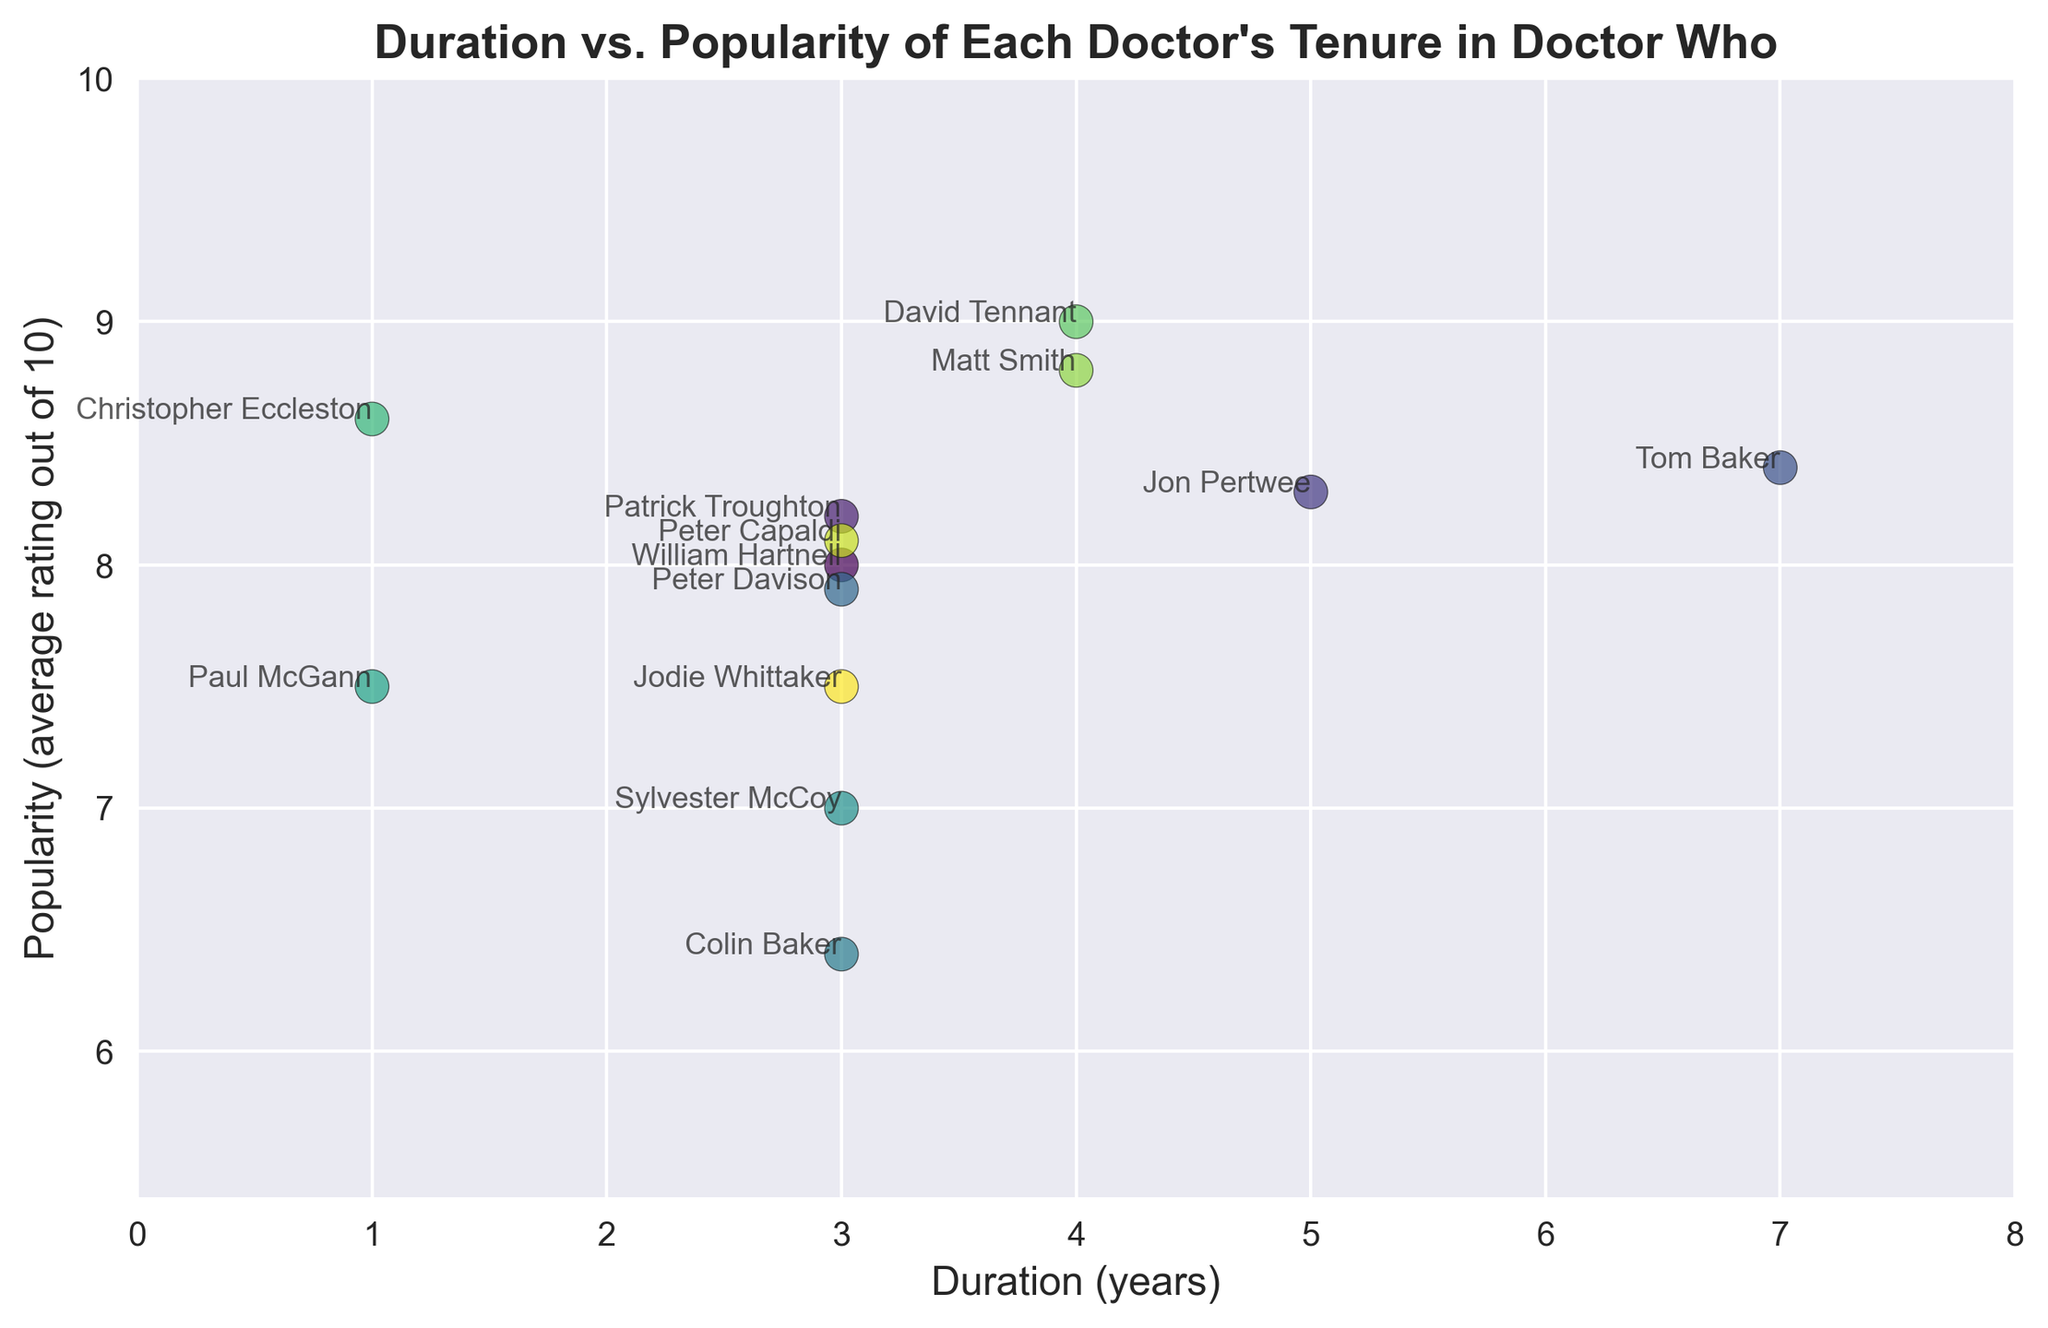Which Doctor had the highest average popularity rating? Look at the y-axis values corresponding to each Doctor. David Tennant has the highest point on the y-axis with a rating of 9.0.
Answer: David Tennant Which Doctor had the lowest average popularity rating? Look at the y-axis values corresponding to each Doctor. Colin Baker has the lowest point on the y-axis with a rating of 6.4.
Answer: Colin Baker What is the total duration of all Doctors who have a popularity rating above 8.0? Identify the Doctors with an average rating above 8.0: William Hartnell, Patrick Troughton, Jon Pertwee, Tom Baker, Christopher Eccleston, David Tennant, Matt Smith, and Peter Capaldi. Sum their durations: 3 + 3 + 5 + 7 + 1 + 4 + 4 + 3 = 30.
Answer: 30 Which Doctor had a tenure duration equal to the average tenure duration for all Doctors? Calculate the average tenure duration: (3 + 3 + 5 + 7 + 3 + 3 + 3 + 1 + 1 + 4 + 4 + 3 + 3) / 13 ≈ 3.23 years. Compare this to each Doctor's duration. None of the durations exactly equal the average.
Answer: None Who are the Doctors with a tenure duration of 3 years, and how do their popularity ratings compare? Identify the Doctors with 3 years tenure: William Hartnell, Patrick Troughton, Peter Davison, Colin Baker, Sylvester McCoy, Peter Capaldi, and Jodie Whittaker. Compare their ratings: 8.0, 8.2, 7.9, 6.4, 7.0, 8.1, and 7.5 respectively. Highest is Patrick Troughton (8.2), and lowest is Colin Baker (6.4).
Answer: Patrick Troughton, Colin Baker What is the average rating for Doctors who served less than 4 years? Identify the Doctors who served less than 4 years: William Hartnell, Patrick Troughton, Peter Davison, Colin Baker, Sylvester McCoy, Paul McGann, Christopher Eccleston, and Jodie Whittaker. Their ratings: 8.0, 8.2, 7.9, 6.4, 7.0, 7.5, 8.6, 7.5. Calculate the average: (8.0 + 8.2 + 7.9 + 6.4 + 7.0 + 7.5 + 8.6 + 7.5) / 8 ≈ 7.64.
Answer: 7.64 Who is the Doctor with the closest popularity rating to 8.0, and what is their tenure duration? Identify the Doctor with the closest rating to 8.0: William Hartnell (8.0), Peter Davison (7.9), Peter Capaldi (8.1). William Hartnell has the exact rating of 8.0 with a duration of 3 years.
Answer: William Hartnell, 3 years 